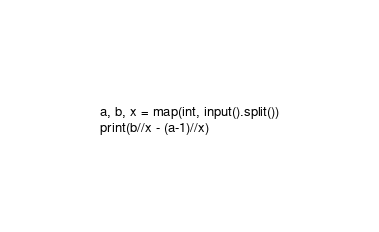<code> <loc_0><loc_0><loc_500><loc_500><_Python_>a, b, x = map(int, input().split())
print(b//x - (a-1)//x)
</code> 